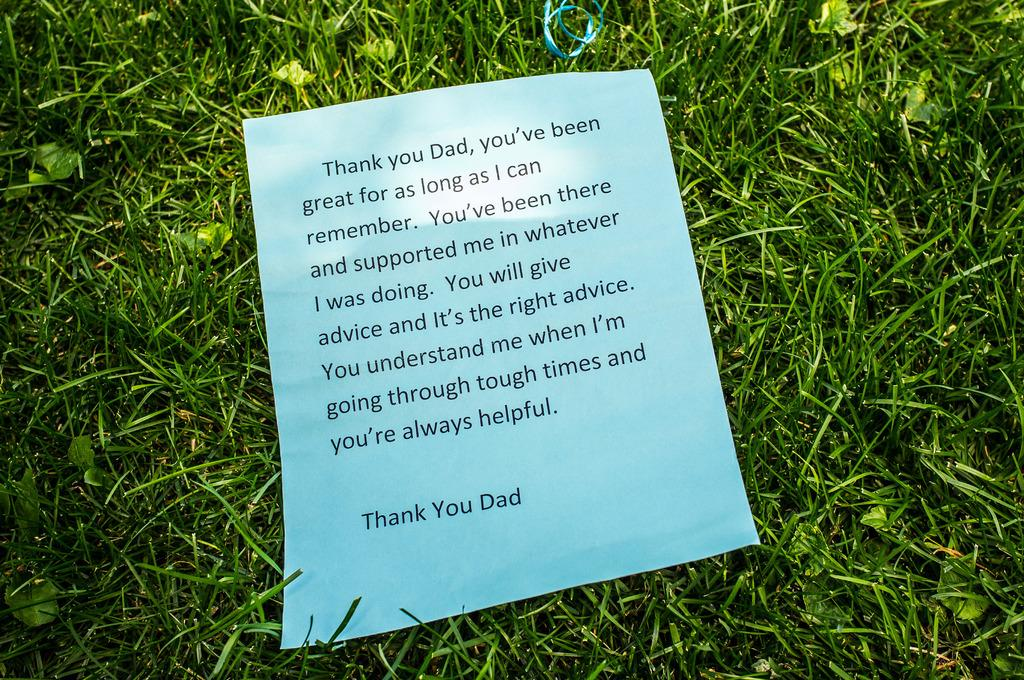What type of vegetation is present in the image? There is grass in the image. What is the color of the grass? The grass is green in color. What object is placed on the grass? There is a paper on the grass. What can be seen on the paper? Something is written on the paper. Is there a swing in the image? No, there is no swing present in the image. 